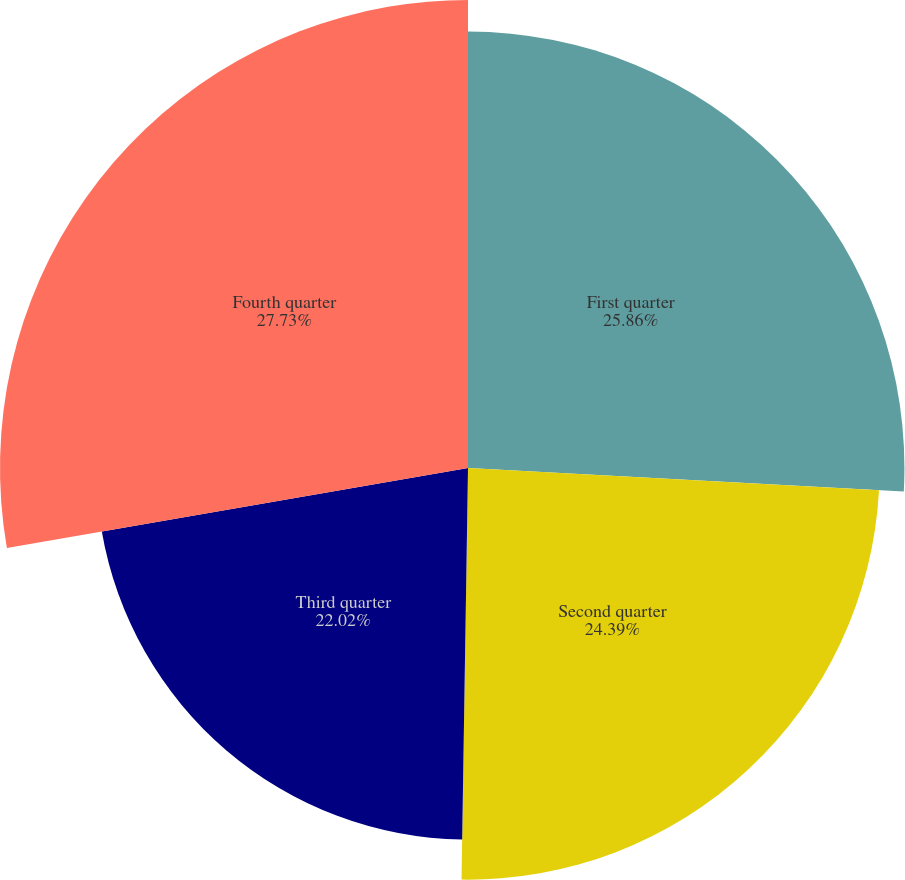Convert chart to OTSL. <chart><loc_0><loc_0><loc_500><loc_500><pie_chart><fcel>First quarter<fcel>Second quarter<fcel>Third quarter<fcel>Fourth quarter<nl><fcel>25.86%<fcel>24.39%<fcel>22.02%<fcel>27.73%<nl></chart> 